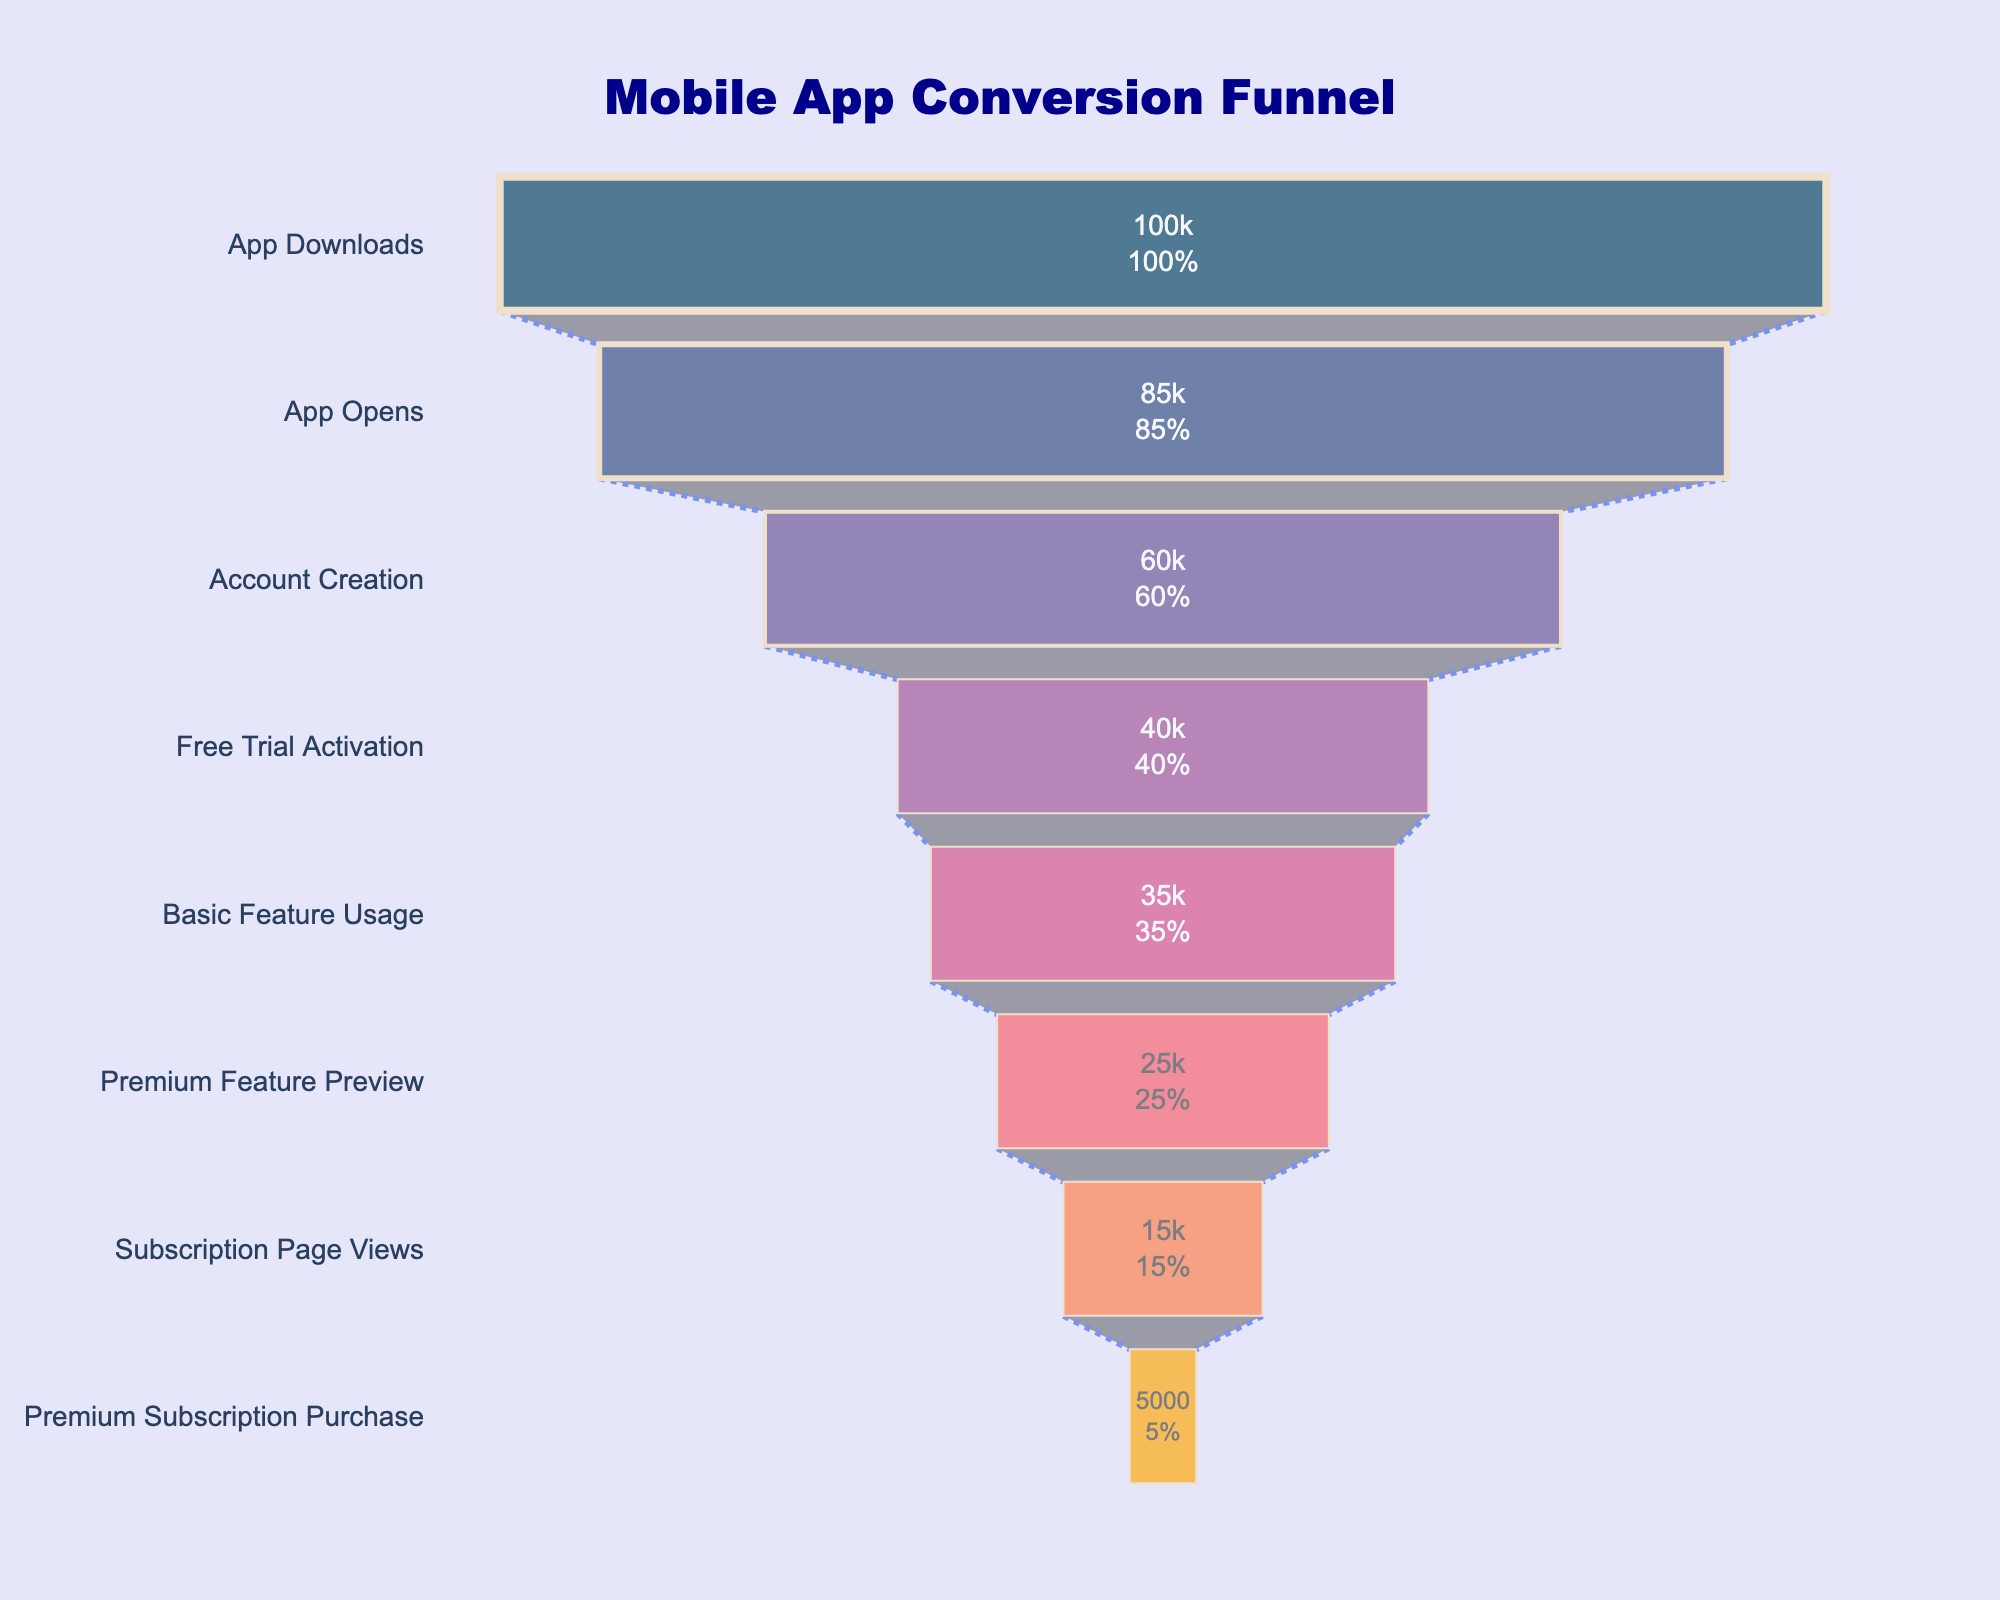How many users created an account? Look at the value associated with the "Account Creation" step.
Answer: 60,000 What percentage of initial app downloads led to premium subscription purchases? Look at the "Premium Subscription Purchase" step and the "App Downloads" step. Calculate the percentage as (5000 / 100000) * 100.
Answer: 5% Which step has the largest drop in user count? Compare the differences in user counts between consecutive steps. The largest drop is from "Account Creation" (60,000 users) to "Free Trial Activation" (40,000 users), a drop of 20,000 users.
Answer: Account Creation to Free Trial Activation How many users viewed the subscription page? Look at the value associated with the "Subscription Page Views" step.
Answer: 15,000 How many users open the app but did not go on to create an account? Subtract the number of users who created an account from those who opened the app: 85,000 (App Opens) - 60,000 (Account Creation).
Answer: 25,000 What is the percentage drop from basic feature usage to premium feature preview? Calculate the percentage drop as ((35000 - 25000) / 35000) * 100, which is approximately 28.57%.
Answer: 28.57% How many users activated the free trial but did not reach the subscription page view step? Subtract the number of users who viewed the subscription page from those who activated the free trial: 40,000 (Free Trial Activation) - 15,000 (Subscription Page Views).
Answer: 25,000 Which step has the lowest user retention rate? Compare the percentages of user retention at each step. The lowest percentage retained from initial downloads to "Premium Subscription Purchase" is 5%.
Answer: Premium Subscription Purchase What is the total number of users lost from the initial downloads to the subscription page views? Subtract the number of users who viewed the subscription page from the initial downloads: 100,000 (App Downloads) - 15,000 (Subscription Page Views).
Answer: 85,000 How many users used the basic features after activating the free trial? Look at the value associated with the "Basic Feature Usage" step.
Answer: 35,000 